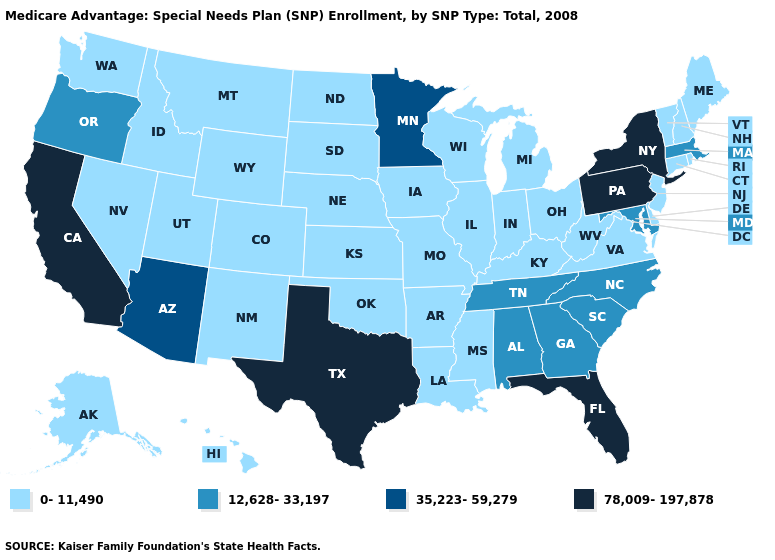What is the value of Vermont?
Keep it brief. 0-11,490. What is the lowest value in the USA?
Short answer required. 0-11,490. Among the states that border Tennessee , which have the lowest value?
Concise answer only. Arkansas, Kentucky, Missouri, Mississippi, Virginia. What is the value of Indiana?
Concise answer only. 0-11,490. What is the lowest value in states that border Maryland?
Concise answer only. 0-11,490. Does Iowa have a lower value than Florida?
Short answer required. Yes. What is the lowest value in the USA?
Give a very brief answer. 0-11,490. What is the highest value in the West ?
Quick response, please. 78,009-197,878. What is the value of Tennessee?
Concise answer only. 12,628-33,197. Does the map have missing data?
Write a very short answer. No. What is the value of Delaware?
Concise answer only. 0-11,490. What is the value of Alabama?
Keep it brief. 12,628-33,197. Name the states that have a value in the range 12,628-33,197?
Give a very brief answer. Alabama, Georgia, Massachusetts, Maryland, North Carolina, Oregon, South Carolina, Tennessee. What is the highest value in the USA?
Concise answer only. 78,009-197,878. What is the lowest value in the Northeast?
Short answer required. 0-11,490. 